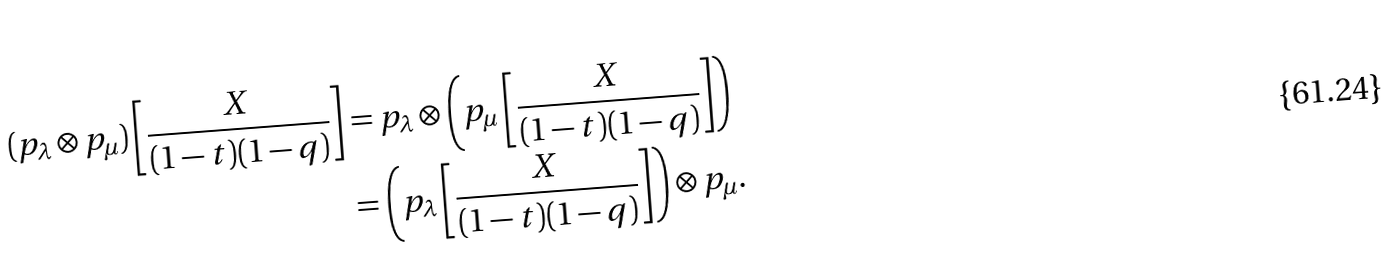<formula> <loc_0><loc_0><loc_500><loc_500>( p _ { \lambda } \otimes p _ { \mu } ) \left [ \frac { X } { ( 1 - t ) ( 1 - q ) } \right ] & = p _ { \lambda } \otimes \left ( p _ { \mu } \left [ \frac { X } { ( 1 - t ) ( 1 - q ) } \right ] \right ) \\ & = \left ( p _ { \lambda } \left [ \frac { X } { ( 1 - t ) ( 1 - q ) } \right ] \right ) \otimes p _ { \mu } .</formula> 